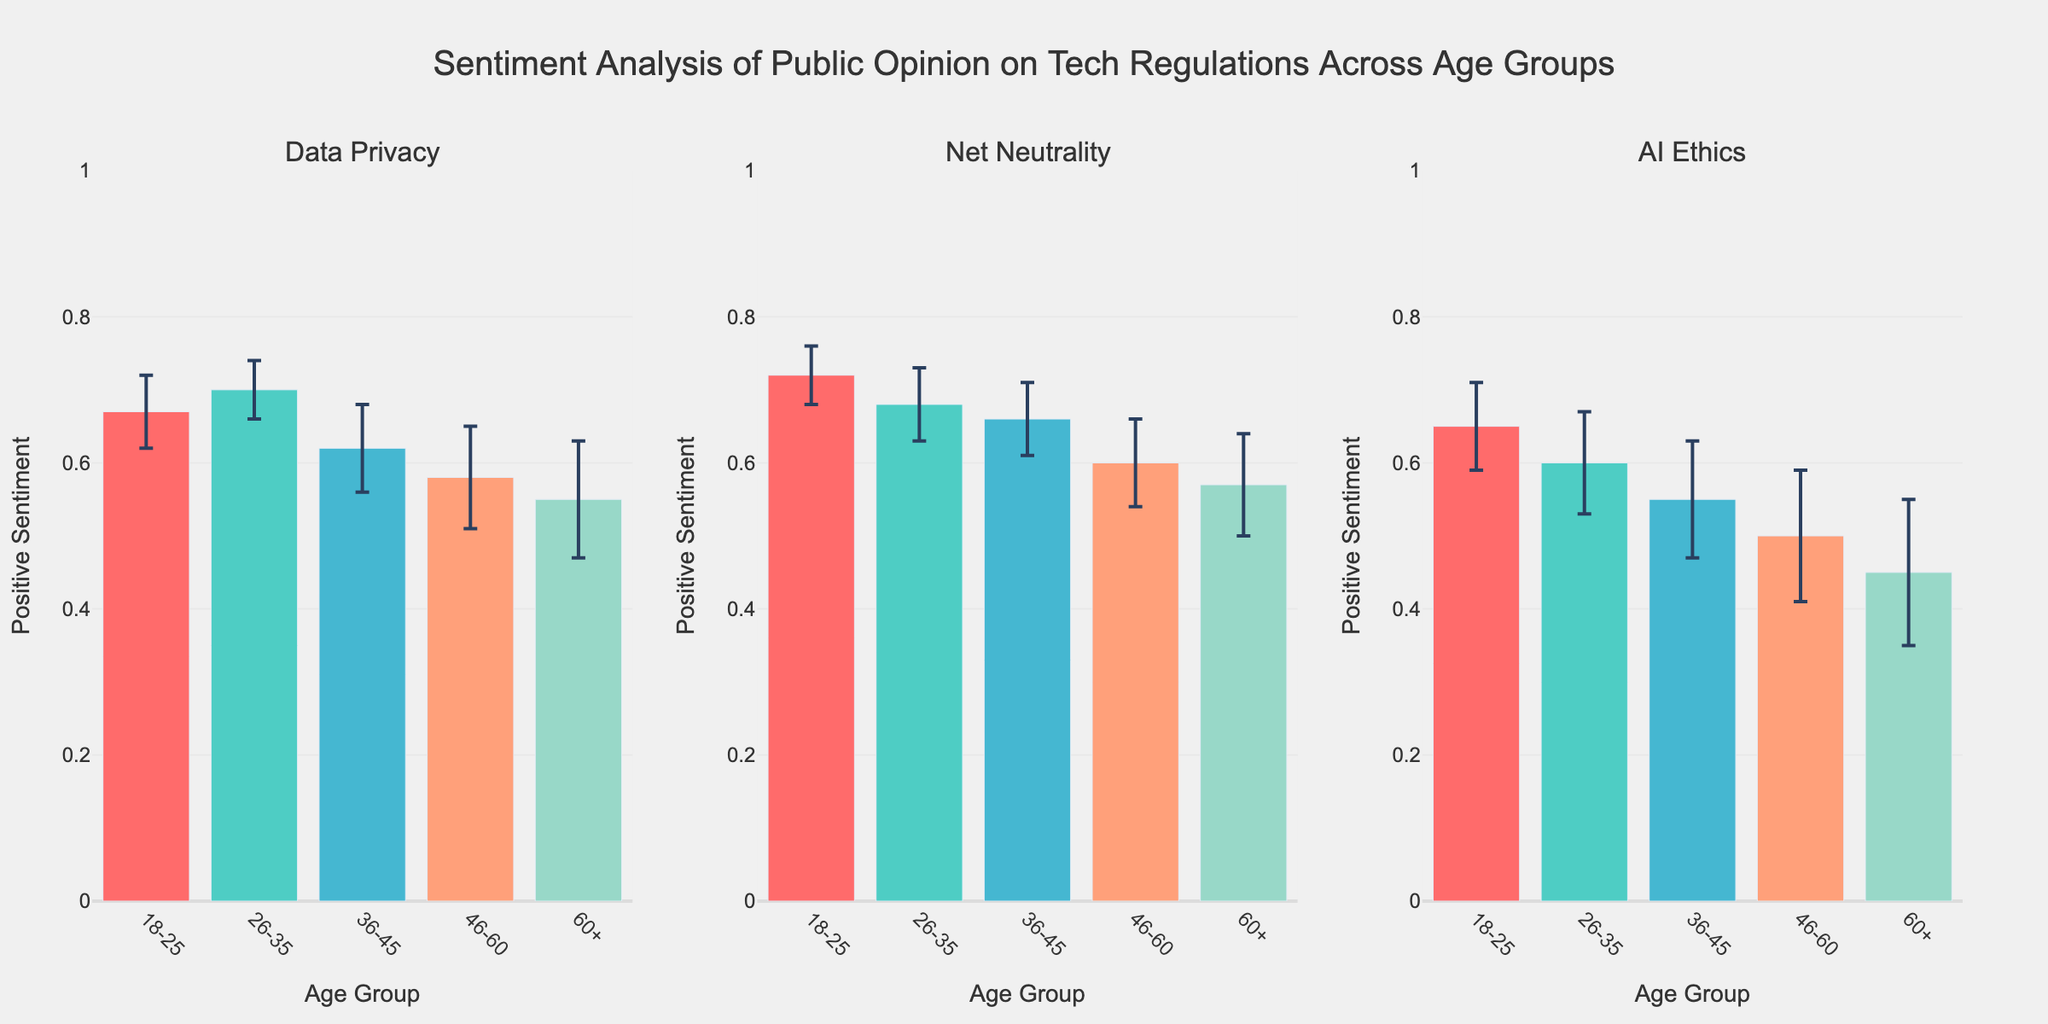What is the title of the plot? The title is the text placed at the top of the figure. Here, it reads "Sentiment Analysis of Public Opinion on Tech Regulations Across Age Groups".
Answer: Sentiment Analysis of Public Opinion on Tech Regulations Across Age Groups Which age group has the highest positive sentiment for Net Neutrality? By examining the bars related to Net Neutrality across age groups, the highest bar corresponds to the 18-25 age group.
Answer: 18-25 What is the positive sentiment value for AI Ethics among the 36-45 age group? For AI Ethics, look at the data in the subplot for the 36-45 age group. The bar height represents the positive sentiment, which is 0.55.
Answer: 0.55 How does the positive sentiment for Data Privacy compare between the 26-35 and 46-60 age groups? Observe the Data Privacy subplot. The bar for the 26-35 age group is taller (0.70) compared to the 46-60 age group (0.58), indicating higher positive sentiment in the 26-35 age group.
Answer: The 26-35 age group has higher positive sentiment Calculate the average positive sentiment for Data Privacy across all age groups. Adding the Data Privacy values for all age groups (0.67 + 0.70 + 0.62 + 0.58 + 0.55) gives 3.12. Dividing by the number of age groups (5) gives an average of 3.12 / 5 = 0.624.
Answer: 0.624 Which age group shows the lowest positive sentiment for any of the tech regulations? Look across all subplots for the tech regulations. The lowest bar is found in the AI Ethics subplot for the 60+ age group, which is 0.45.
Answer: 60+ What are the error bars representing in the figure? Error bars indicate the range of standard error around the positive sentiment values for each age group.
Answer: Standard error Which tech regulation shows the highest positive sentiment among the 18-25 age group? In the 18-25 age group, the tallest bar corresponds to Net Neutrality with a sentiment value of 0.72.
Answer: Net Neutrality For the 36-45 age group, which tech regulation has the smallest error bar range? In the 36-45 age group, compare the length of error bars for each subplot. Net Neutrality has the smallest error bar range.
Answer: Net Neutrality 